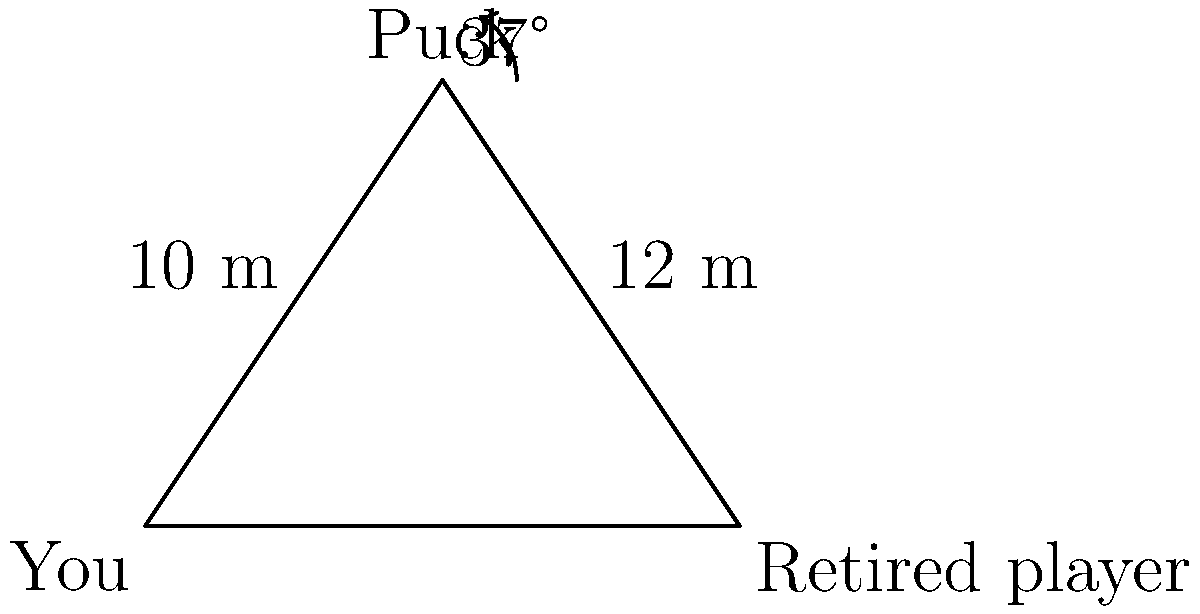During a crucial moment in the championship game, you're positioned 10 meters away from the puck, while the retired player you're competing against is 12 meters away from it. The angle between you, the puck, and the retired player is 37°. Using the law of cosines, calculate the distance between you and the retired player on the ice. Let's approach this step-by-step using the law of cosines:

1) Let's define our variables:
   a = distance between you and the retired player (what we're solving for)
   b = 10 m (distance between you and the puck)
   c = 12 m (distance between the retired player and the puck)
   A = 37° (angle between you, the puck, and the retired player)

2) The law of cosines states:
   $$a^2 = b^2 + c^2 - 2bc \cos(A)$$

3) Let's substitute our known values:
   $$a^2 = 10^2 + 12^2 - 2(10)(12) \cos(37°)$$

4) Simplify:
   $$a^2 = 100 + 144 - 240 \cos(37°)$$

5) Calculate $\cos(37°)$ ≈ 0.7986

6) Substitute and calculate:
   $$a^2 = 100 + 144 - 240(0.7986) = 244 - 191.664 = 52.336$$

7) Take the square root of both sides:
   $$a = \sqrt{52.336} ≈ 7.23$$

Therefore, the distance between you and the retired player is approximately 7.23 meters.
Answer: 7.23 m 